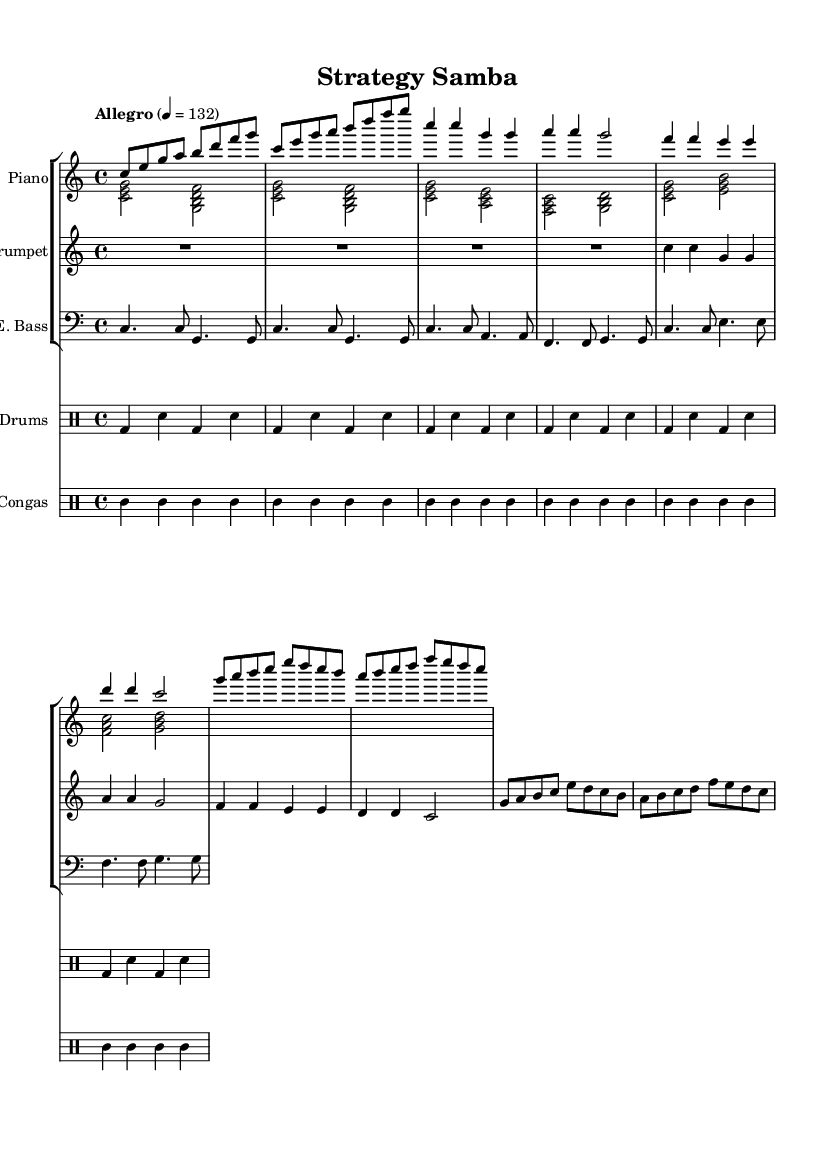What is the key signature of this music? The key signature is C major, which has no sharps or flats.
Answer: C major What is the time signature of this music? The time signature is indicated as 4/4, meaning there are four beats in each measure.
Answer: 4/4 What is the tempo marking of this piece? The tempo marking states "Allegro" at quarter note equals 132, indicating a fast pace.
Answer: Allegro 4 = 132 Which instruments are included in this arrangement? The score indicates piano, trumpet, electric bass, drums, and congas as the instruments used.
Answer: Piano, trumpet, electric bass, drums, congas How many measures are in the introduction section? The introduction section consists of 4 measures as indicated by the time signatures and rhythms.
Answer: 4 measures What is the rhythmic pattern used in the congas part? The rhythmic pattern is alternating between notes on beats, generally keeping a consistent groove throughout.
Answer: Alternating groove What type of music is this? This piece exemplifies an upbeat Latin jazz fusion style, blending various rhythmic and melodic elements characteristic of both genres.
Answer: Upbeat Latin jazz fusion 